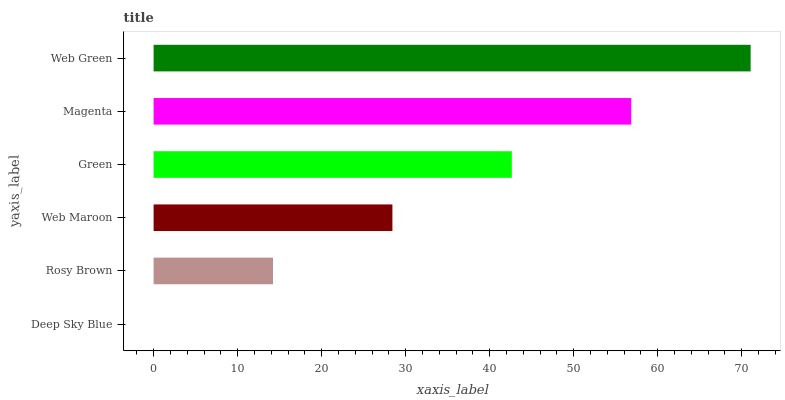Is Deep Sky Blue the minimum?
Answer yes or no. Yes. Is Web Green the maximum?
Answer yes or no. Yes. Is Rosy Brown the minimum?
Answer yes or no. No. Is Rosy Brown the maximum?
Answer yes or no. No. Is Rosy Brown greater than Deep Sky Blue?
Answer yes or no. Yes. Is Deep Sky Blue less than Rosy Brown?
Answer yes or no. Yes. Is Deep Sky Blue greater than Rosy Brown?
Answer yes or no. No. Is Rosy Brown less than Deep Sky Blue?
Answer yes or no. No. Is Green the high median?
Answer yes or no. Yes. Is Web Maroon the low median?
Answer yes or no. Yes. Is Rosy Brown the high median?
Answer yes or no. No. Is Magenta the low median?
Answer yes or no. No. 